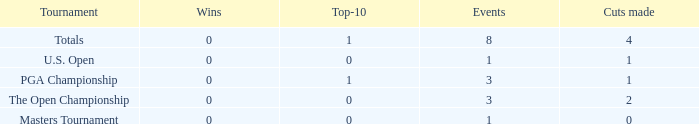For majors with 8 events played and more than 1 made cut, what is the most top-10s recorded? 1.0. 